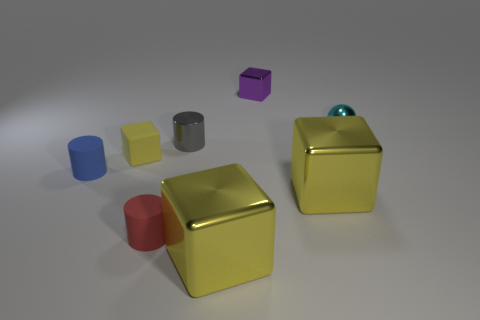Subtract all yellow blocks. How many were subtracted if there are1yellow blocks left? 2 Subtract all purple cubes. How many cubes are left? 3 Subtract all tiny yellow cubes. How many cubes are left? 3 Subtract all yellow cubes. How many cyan cylinders are left? 0 Add 2 tiny metal blocks. How many objects exist? 10 Subtract 3 cubes. How many cubes are left? 1 Subtract all tiny objects. Subtract all tiny blue matte objects. How many objects are left? 1 Add 4 small purple shiny blocks. How many small purple shiny blocks are left? 5 Add 7 large cyan metallic spheres. How many large cyan metallic spheres exist? 7 Subtract 0 green spheres. How many objects are left? 8 